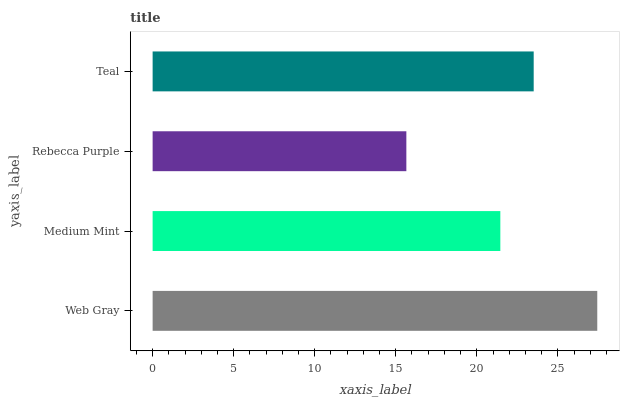Is Rebecca Purple the minimum?
Answer yes or no. Yes. Is Web Gray the maximum?
Answer yes or no. Yes. Is Medium Mint the minimum?
Answer yes or no. No. Is Medium Mint the maximum?
Answer yes or no. No. Is Web Gray greater than Medium Mint?
Answer yes or no. Yes. Is Medium Mint less than Web Gray?
Answer yes or no. Yes. Is Medium Mint greater than Web Gray?
Answer yes or no. No. Is Web Gray less than Medium Mint?
Answer yes or no. No. Is Teal the high median?
Answer yes or no. Yes. Is Medium Mint the low median?
Answer yes or no. Yes. Is Rebecca Purple the high median?
Answer yes or no. No. Is Web Gray the low median?
Answer yes or no. No. 